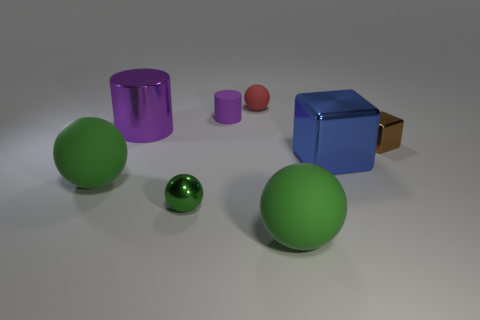Subtract all green balls. How many were subtracted if there are1green balls left? 2 Add 1 large metallic cylinders. How many objects exist? 9 Subtract all matte spheres. How many spheres are left? 1 Subtract all purple cylinders. How many green balls are left? 3 Subtract all red balls. How many balls are left? 3 Subtract all gray blocks. Subtract all blue balls. How many blocks are left? 2 Subtract all small green objects. Subtract all red rubber objects. How many objects are left? 6 Add 5 big shiny cylinders. How many big shiny cylinders are left? 6 Add 8 cyan blocks. How many cyan blocks exist? 8 Subtract 0 green cylinders. How many objects are left? 8 